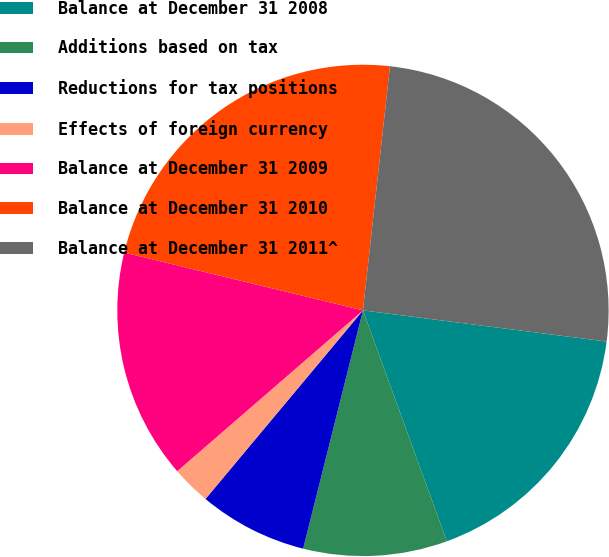Convert chart to OTSL. <chart><loc_0><loc_0><loc_500><loc_500><pie_chart><fcel>Balance at December 31 2008<fcel>Additions based on tax<fcel>Reductions for tax positions<fcel>Effects of foreign currency<fcel>Balance at December 31 2009<fcel>Balance at December 31 2010<fcel>Balance at December 31 2011^<nl><fcel>17.43%<fcel>9.46%<fcel>7.16%<fcel>2.57%<fcel>15.14%<fcel>22.97%<fcel>25.27%<nl></chart> 